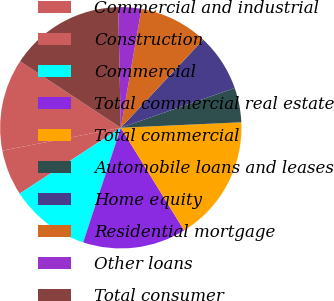<chart> <loc_0><loc_0><loc_500><loc_500><pie_chart><fcel>Commercial and industrial<fcel>Construction<fcel>Commercial<fcel>Total commercial real estate<fcel>Total commercial<fcel>Automobile loans and leases<fcel>Home equity<fcel>Residential mortgage<fcel>Other loans<fcel>Total consumer<nl><fcel>12.31%<fcel>6.15%<fcel>10.77%<fcel>13.85%<fcel>16.92%<fcel>4.62%<fcel>7.69%<fcel>9.23%<fcel>3.08%<fcel>15.38%<nl></chart> 